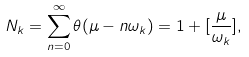<formula> <loc_0><loc_0><loc_500><loc_500>N _ { k } = \sum _ { n = 0 } ^ { \infty } \theta ( \mu - n \omega _ { k } ) = 1 + [ \frac { \mu } { \omega _ { k } } ] ,</formula> 